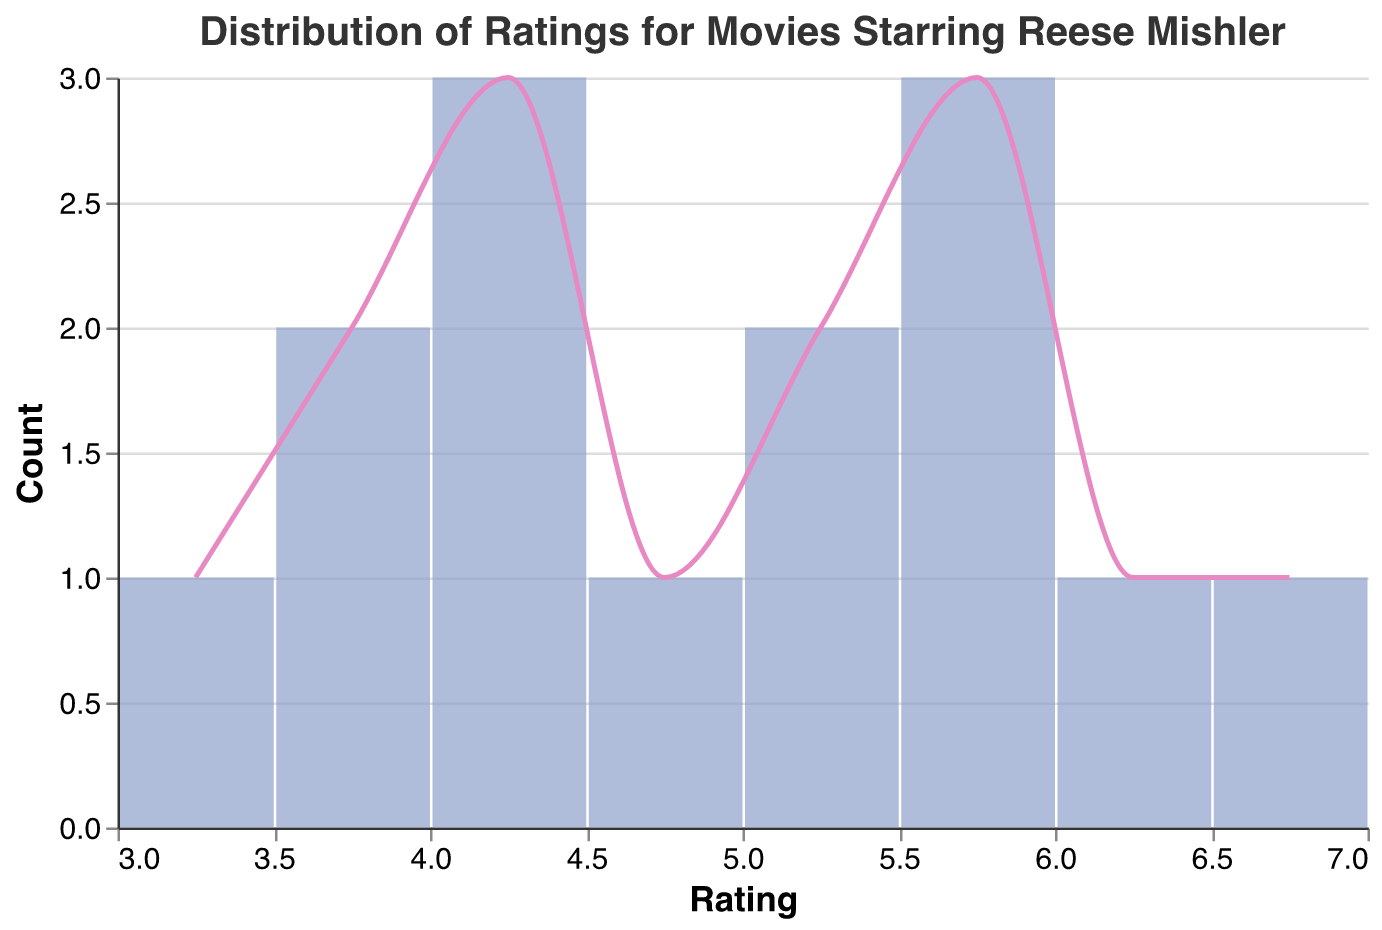What is the title of the figure? The title of the figure is usually the first text provided at the top, giving a clear description of what the figure represents. Here, it states "Distribution of Ratings for Movies Starring Reese Mishler."
Answer: Distribution of Ratings for Movies Starring Reese Mishler How many movies are rated? You can count the number of individual points or bars representing ratings for each movie. The data shows there are 14 movies listed.
Answer: 14 Which year has the highest number of movies rated in the dataset? To determine this, group the data by each year and count the number of movies in each year. Here, only the years 2018, 2019, 2020, 2021, 2022, and 2023 have more than one movie listed. Among these, 2018, 2019, and 2023 have the highest count with 2 movies each.
Answer: 2018, 2019, and 2023 What is the range of ratings in the figure? The range is the difference between the highest and lowest values on the x-axis. The lowest rating is 3.2 and the highest rating is 6.8, so the range is 6.8 - 3.2.
Answer: 3.6 Which rating bin has the highest count of movies? Look for the tallest bar in the bar plot, which represents the rating bin with the highest frequency of movies. The bin around rating 4 has the highest count with 5 movies.
Answer: Around 4 How many movies have a rating above 5.0? Identify the bars representing ratings greater than 5.0 and add their counts: Ratings above 5.0 are 5.2, 5.3, 5.5, 5.7, 5.8, 6.1, and 6.8 summing up to 7 movies.
Answer: 7 Compare the number of movies rated above 5.0 with those rated below 5.0. Which is more? Count the number of movies with ratings above 5.0 (7 movies) and below 5.0 (7 movies). Both counts are equal.
Answer: They are equal What can be inferred about the general trend of movie ratings for Reese Mishler over the years? Observing the rating distribution over the years, there doesn't appear to be a consistent trend of improvement or decline. Ratings are spread across various values without a clear upward or downward trend.
Answer: No clear trend Which movie has the highest rating, and what is its rating? Look for the highest point on the x-axis. The highest rating is 6.8, which corresponds to "In the Blink of an Eye."
Answer: In the Blink of an Eye, 6.8 